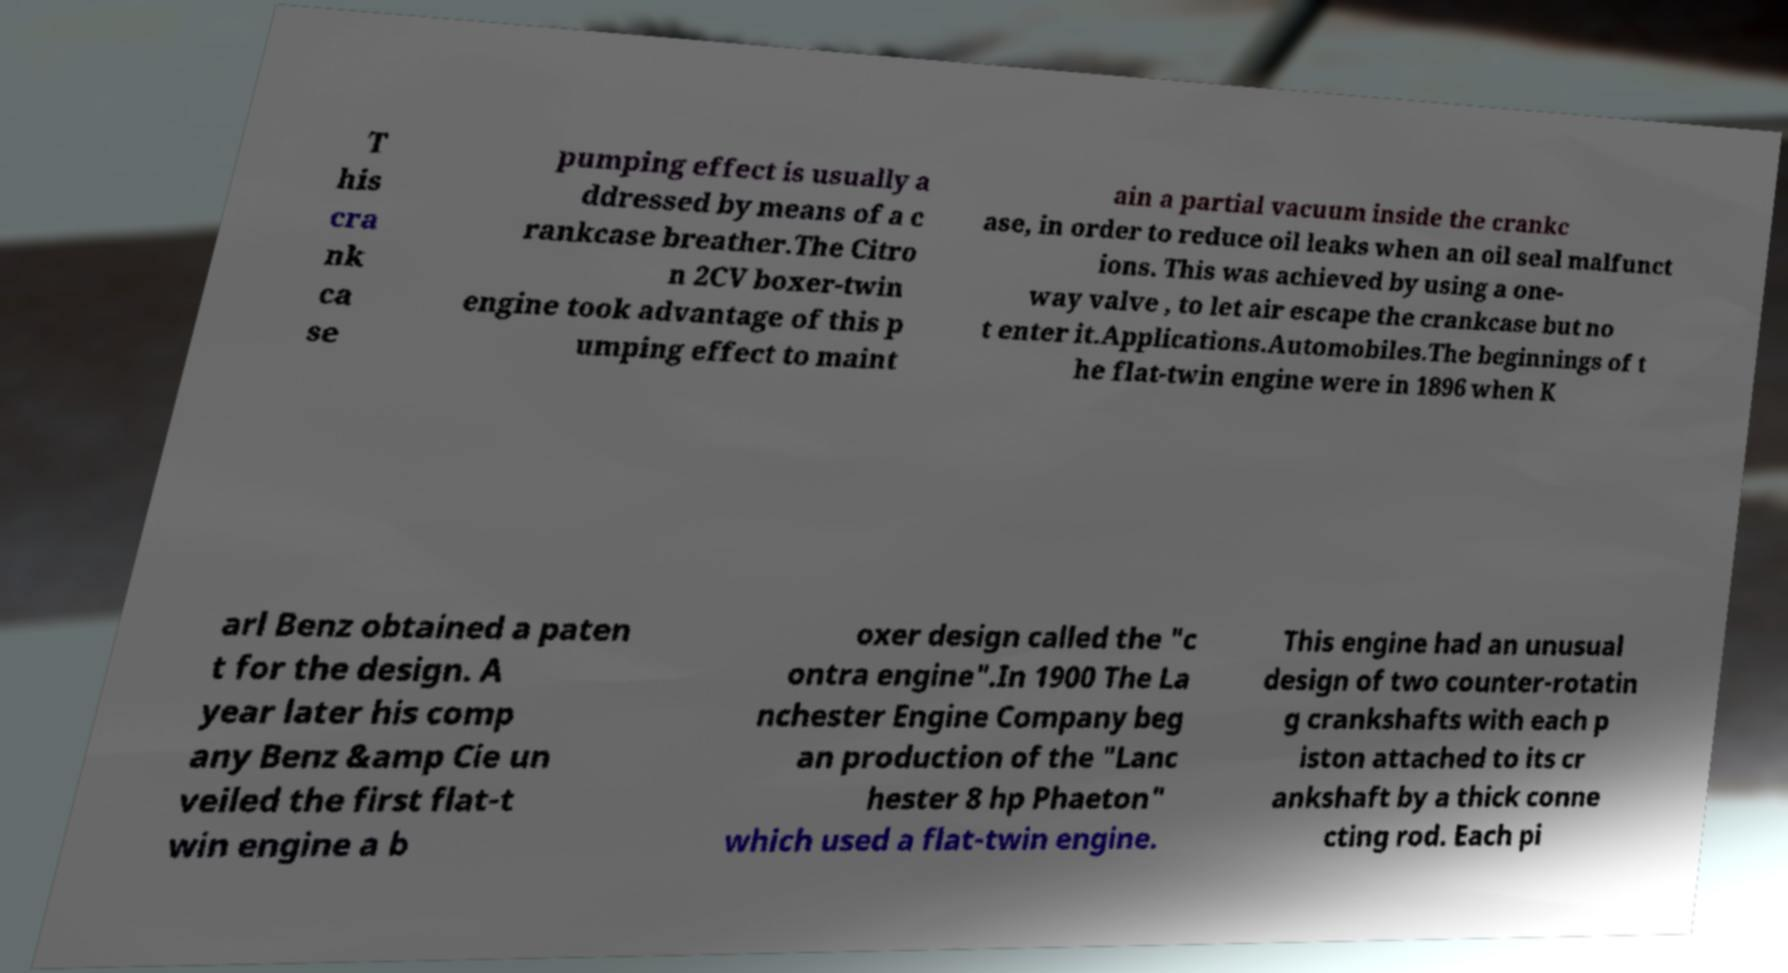Can you read and provide the text displayed in the image?This photo seems to have some interesting text. Can you extract and type it out for me? T his cra nk ca se pumping effect is usually a ddressed by means of a c rankcase breather.The Citro n 2CV boxer-twin engine took advantage of this p umping effect to maint ain a partial vacuum inside the crankc ase, in order to reduce oil leaks when an oil seal malfunct ions. This was achieved by using a one- way valve , to let air escape the crankcase but no t enter it.Applications.Automobiles.The beginnings of t he flat-twin engine were in 1896 when K arl Benz obtained a paten t for the design. A year later his comp any Benz &amp Cie un veiled the first flat-t win engine a b oxer design called the "c ontra engine".In 1900 The La nchester Engine Company beg an production of the "Lanc hester 8 hp Phaeton" which used a flat-twin engine. This engine had an unusual design of two counter-rotatin g crankshafts with each p iston attached to its cr ankshaft by a thick conne cting rod. Each pi 